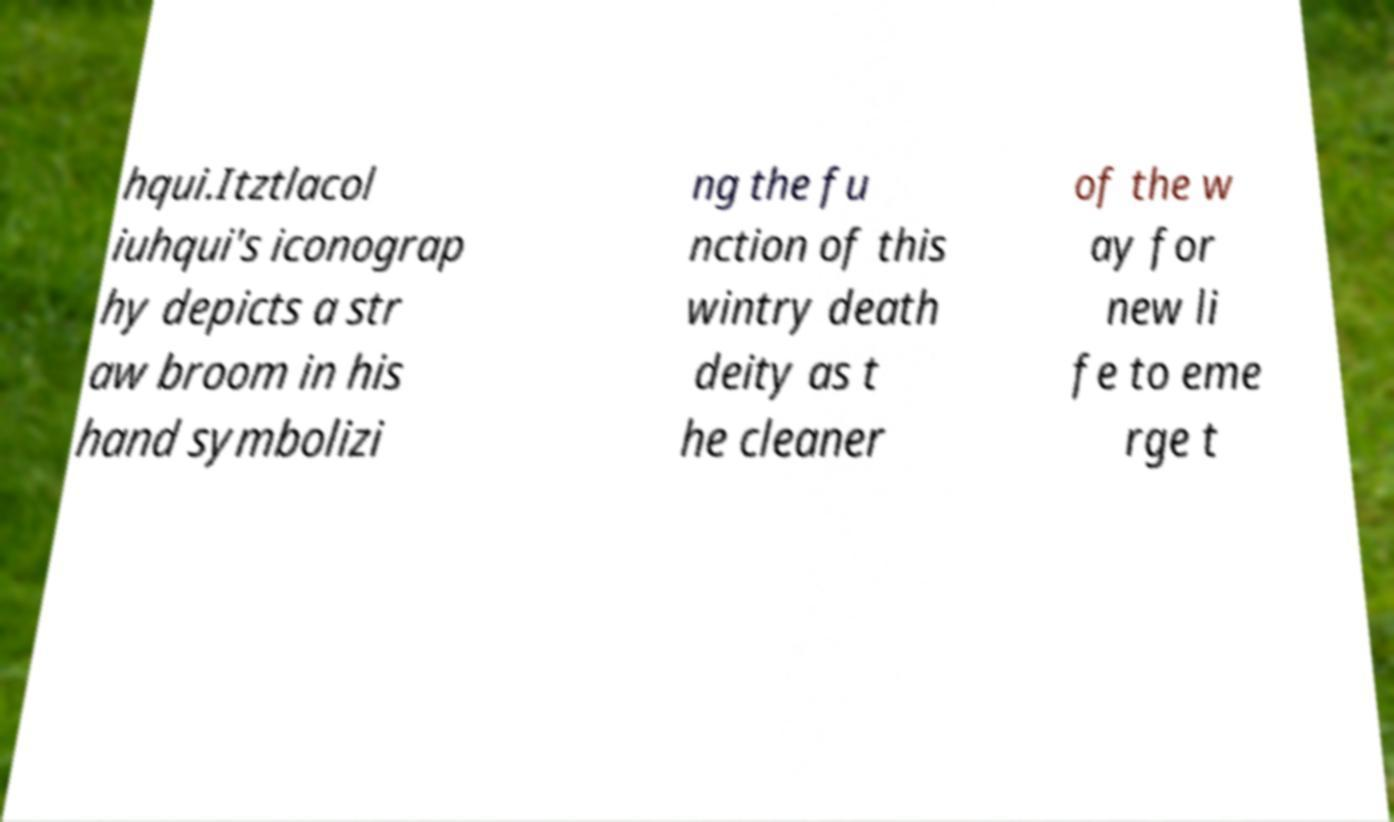What messages or text are displayed in this image? I need them in a readable, typed format. hqui.Itztlacol iuhqui's iconograp hy depicts a str aw broom in his hand symbolizi ng the fu nction of this wintry death deity as t he cleaner of the w ay for new li fe to eme rge t 